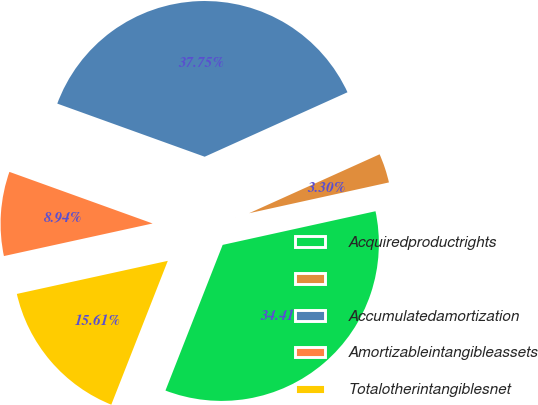Convert chart to OTSL. <chart><loc_0><loc_0><loc_500><loc_500><pie_chart><fcel>Acquiredproductrights<fcel>Unnamed: 1<fcel>Accumulatedamortization<fcel>Amortizableintangibleassets<fcel>Totalotherintangiblesnet<nl><fcel>34.41%<fcel>3.3%<fcel>37.75%<fcel>8.94%<fcel>15.61%<nl></chart> 